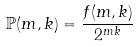<formula> <loc_0><loc_0><loc_500><loc_500>\mathbb { P } ( m , k ) = \frac { f ( m , k ) } { 2 ^ { m k } }</formula> 